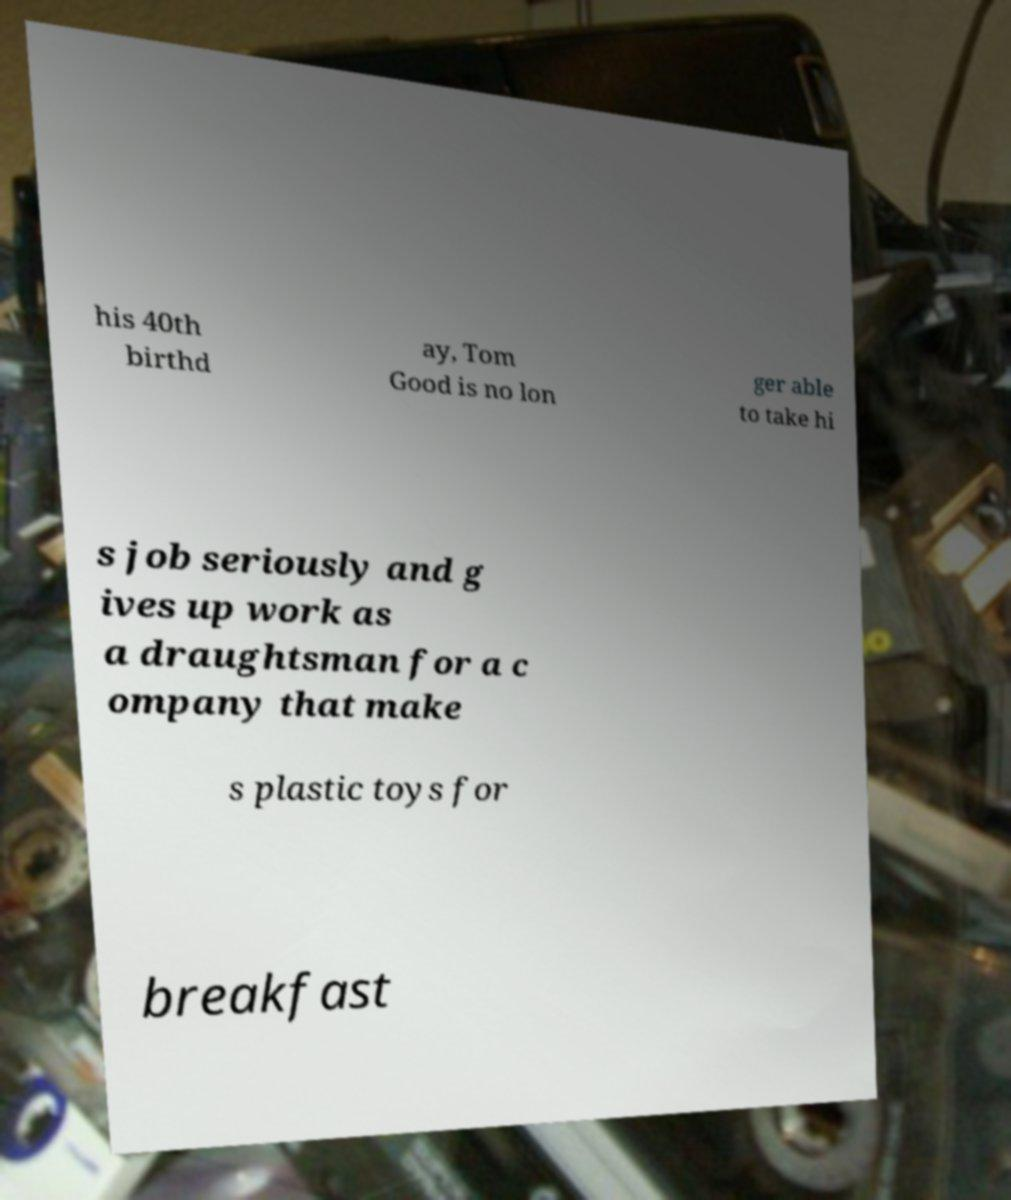What messages or text are displayed in this image? I need them in a readable, typed format. his 40th birthd ay, Tom Good is no lon ger able to take hi s job seriously and g ives up work as a draughtsman for a c ompany that make s plastic toys for breakfast 